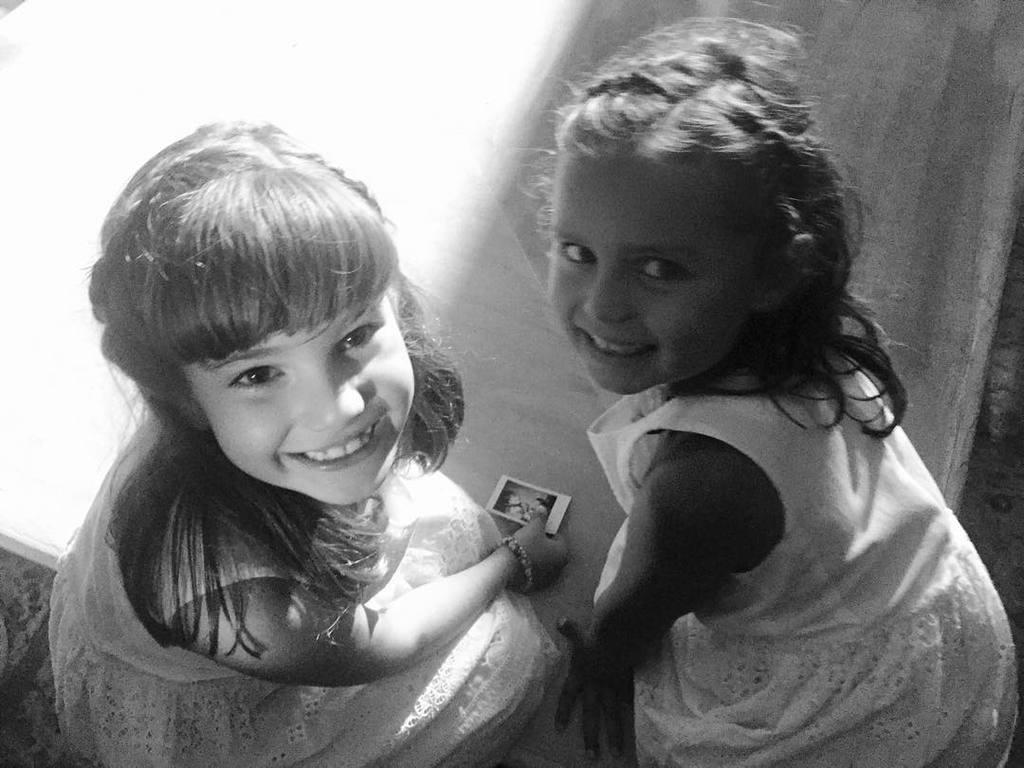How many people are in the image? There are two girls in the image. What are the girls doing in the image? The girls are sitting and smiling. Can you describe what one of the girls is holding? One girl is holding something in her hand. What type of drug is the girl holding in the image? There is no drug present in the image; one girl is simply holding something in her hand. What kind of meat is being prepared by the girls in the image? There is no meat or cooking activity depicted in the image; the girls are sitting and smiling. 